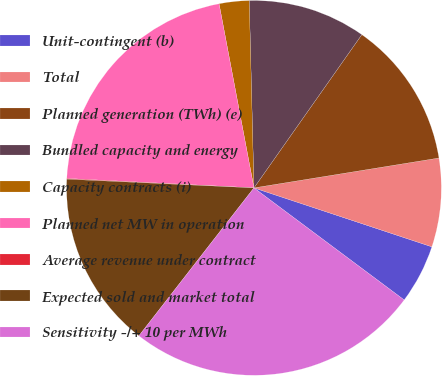Convert chart. <chart><loc_0><loc_0><loc_500><loc_500><pie_chart><fcel>Unit-contingent (b)<fcel>Total<fcel>Planned generation (TWh) (e)<fcel>Bundled capacity and energy<fcel>Capacity contracts (i)<fcel>Planned net MW in operation<fcel>Average revenue under contract<fcel>Expected sold and market total<fcel>Sensitivity -/+ 10 per MWh<nl><fcel>5.11%<fcel>7.64%<fcel>12.69%<fcel>10.16%<fcel>2.58%<fcel>21.22%<fcel>0.06%<fcel>15.22%<fcel>25.32%<nl></chart> 